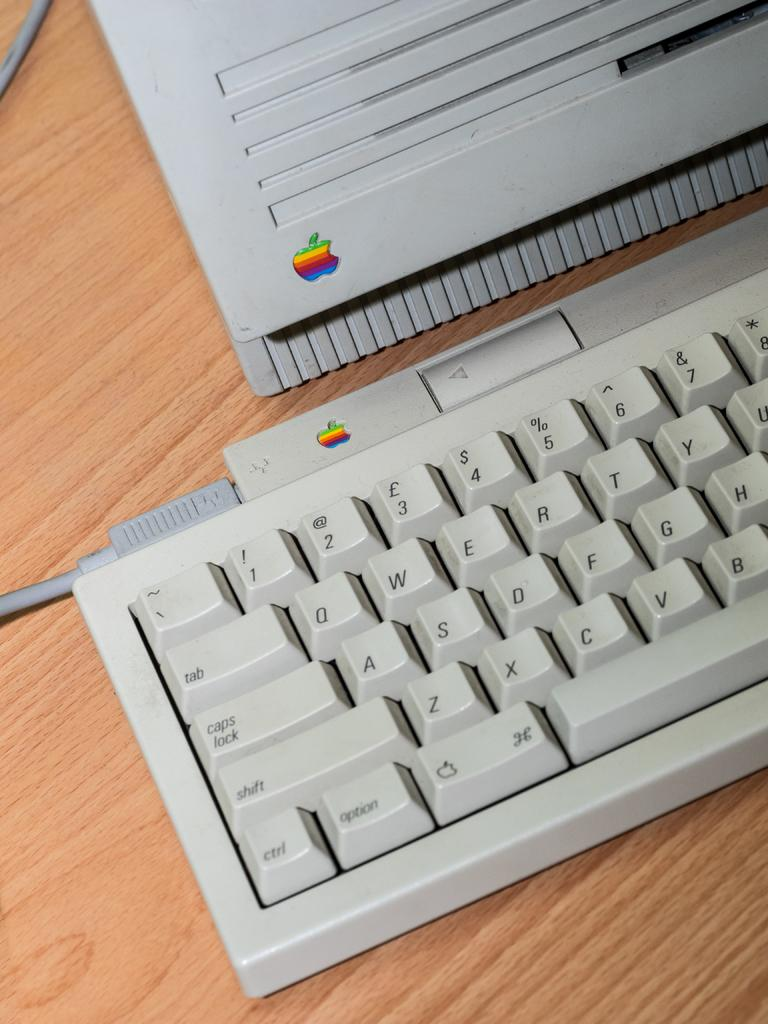<image>
Present a compact description of the photo's key features. An apple keyboard sits on a wooden table 